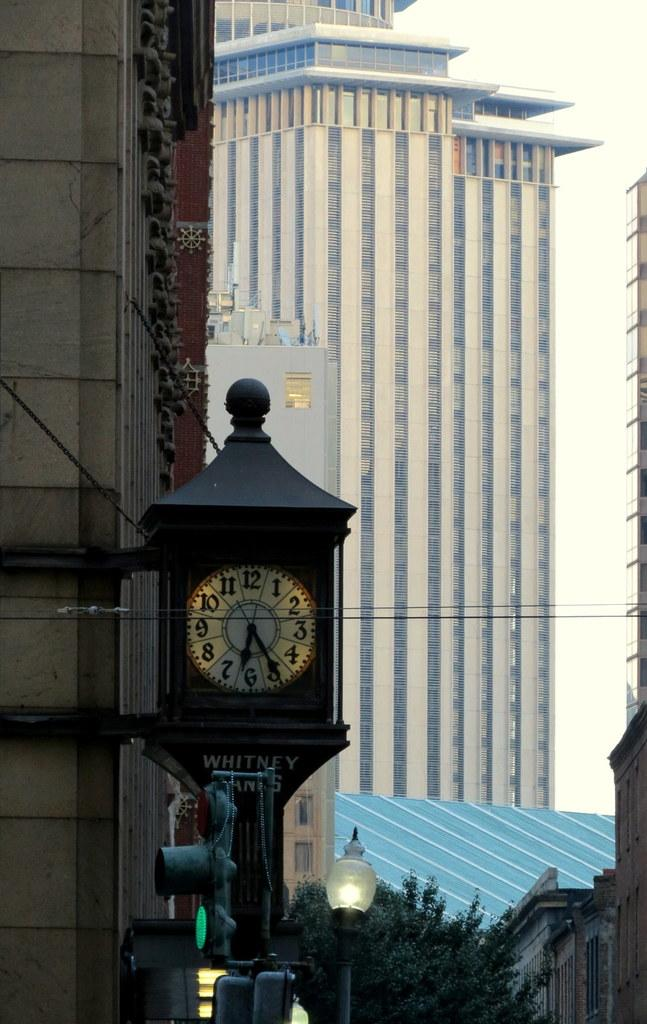<image>
Present a compact description of the photo's key features. a clock that has 1 to 12 on it 